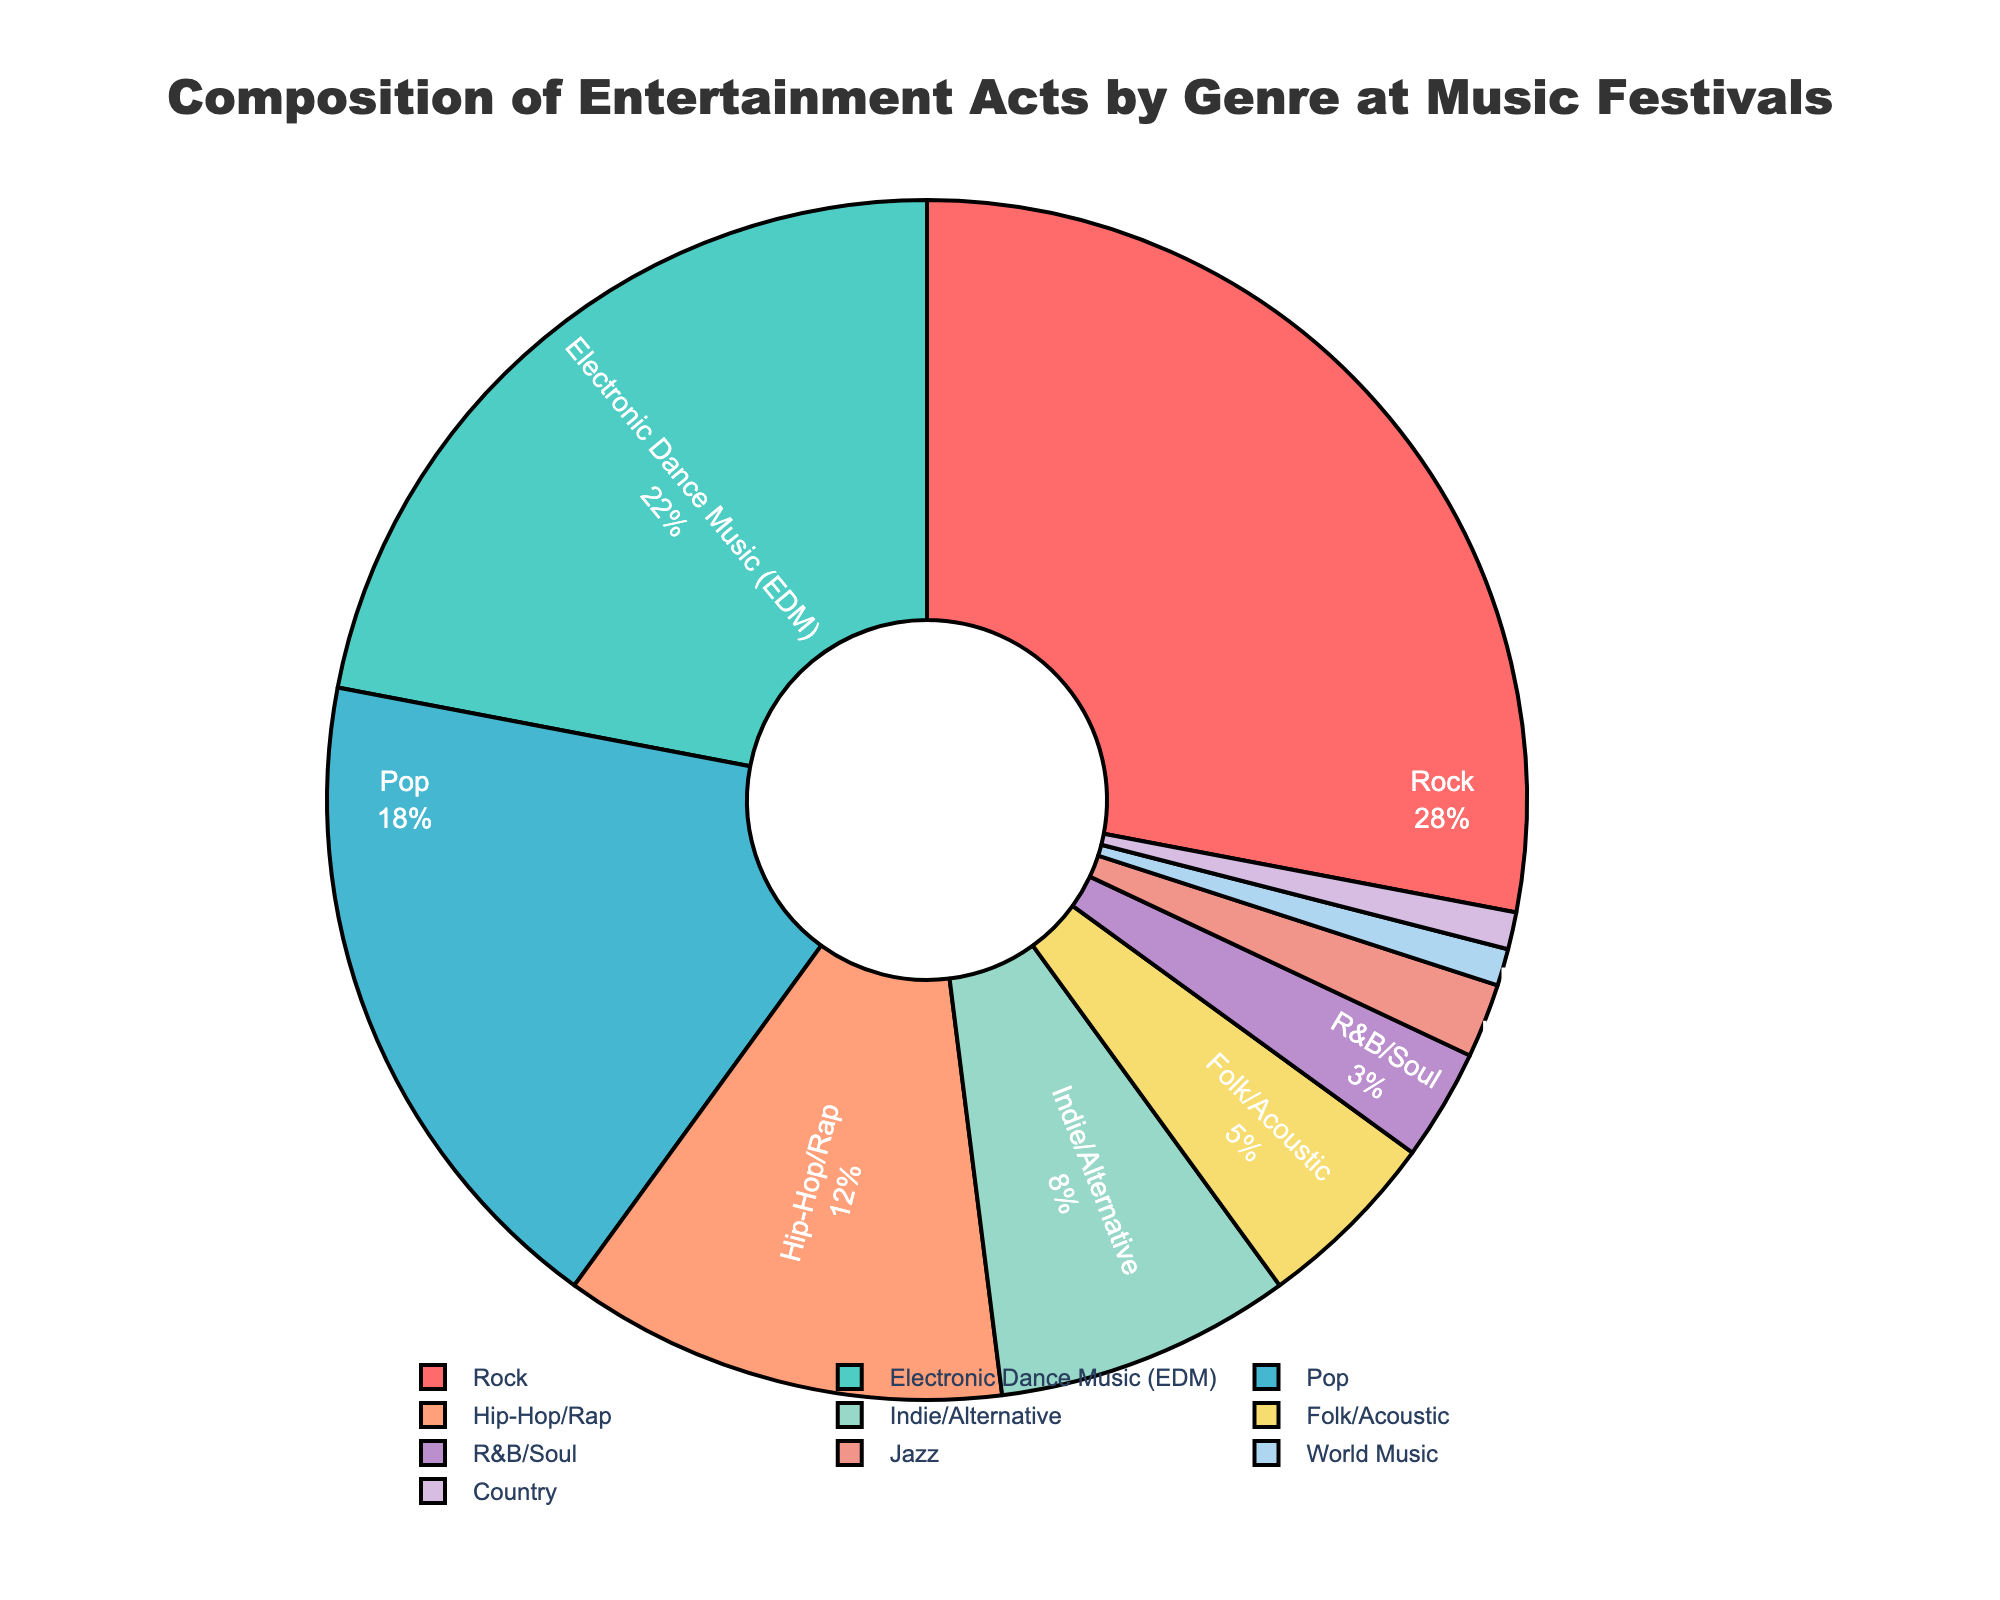What percentage of acts are from Rock and Electronic Dance Music combined? To calculate the combined percentage, sum the individual percentages of Rock and Electronic Dance Music. Rock is 28% and Electronic Dance Music (EDM) is 22%. Therefore, the combined percentage is 28 + 22 = 50%
Answer: 50% Which genre has the smallest representation and what is its percentage? To find the genre with the smallest representation, look for the genre with the lowest percentage. The smallest values in the chart are World Music and Country, each with 1%.
Answer: World Music and Country (1% each) What is the difference in percentage between Pop and Hip-Hop/Rap acts? Subtract the percentage of Hip-Hop/Rap from the percentage of Pop acts. Pop is 18%, and Hip-Hop/Rap is 12%. Therefore, the difference is 18 - 12 = 6%
Answer: 6% Are there more Folk/Acoustic acts or Indie/Alternative acts? Compare the percentages of Folk/Acoustic and Indie/Alternative. Folk/Acoustic has 5%, and Indie/Alternative has 8%. Indie/Alternative has a higher percentage than Folk/Acoustic.
Answer: Indie/Alternative Which genre has a greater percentage: Jazz or R&B/Soul? Compare the percentages of Jazz and R&B/Soul. Jazz has 2%, and R&B/Soul has 3%. R&B/Soul has a higher percentage than Jazz.
Answer: R&B/Soul How much greater is the percentage of Rock acts compared to Folk/Acoustic acts? Subtract the percentage of Folk/Acoustic from the percentage of Rock to find the difference. Rock is 28%, and Folk/Acoustic is 5%. The difference is 28 - 5 = 23%.
Answer: 23% What is the combined percentage for genres making up less than 5% each? Sum the percentages of genres with less than 5%, which are Jazz (2%), World Music (1%), and Country (1%). The combined percentage is 2 + 1 + 1 = 4%.
Answer: 4% Which genre has the second-highest representation in the chart? Identify the genre with the highest representation and then look for the genre with the second-highest. The highest is Rock with 28%, and the second-highest is Electronic Dance Music (EDM) with 22%.
Answer: Electronic Dance Music (EDM) 